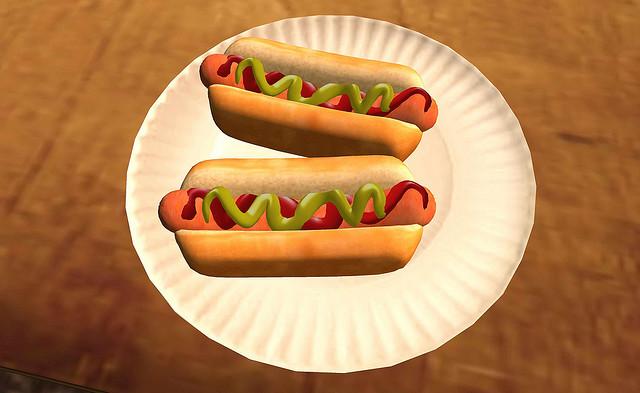Is this food real?
Quick response, please. No. What is on the hot dog?
Keep it brief. Ketchup and mustard. Is this a modern painting?
Short answer required. Yes. 